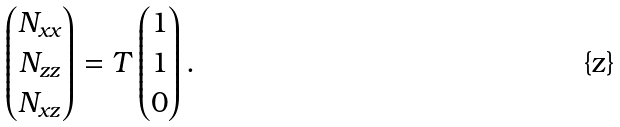<formula> <loc_0><loc_0><loc_500><loc_500>\begin{pmatrix} N _ { x x } \\ N _ { z z } \\ N _ { x z } \end{pmatrix} = T \begin{pmatrix} 1 \\ 1 \\ 0 \end{pmatrix} .</formula> 